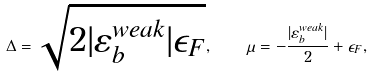Convert formula to latex. <formula><loc_0><loc_0><loc_500><loc_500>\Delta = \sqrt { 2 | \varepsilon _ { b } ^ { w e a k } | \epsilon _ { F } } , \quad \mu = - \frac { | \varepsilon _ { b } ^ { w e a k } | } { 2 } + \epsilon _ { F } ,</formula> 